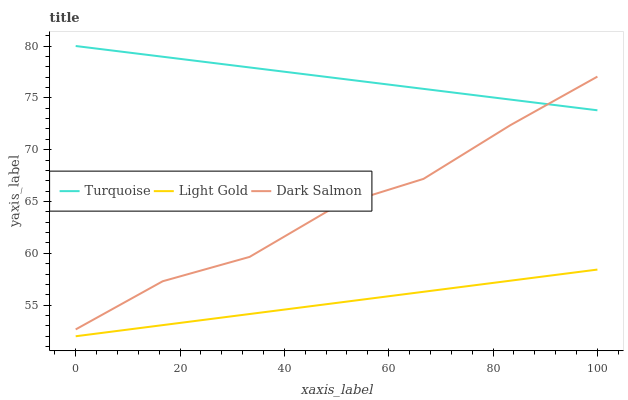Does Light Gold have the minimum area under the curve?
Answer yes or no. Yes. Does Turquoise have the maximum area under the curve?
Answer yes or no. Yes. Does Dark Salmon have the minimum area under the curve?
Answer yes or no. No. Does Dark Salmon have the maximum area under the curve?
Answer yes or no. No. Is Turquoise the smoothest?
Answer yes or no. Yes. Is Dark Salmon the roughest?
Answer yes or no. Yes. Is Dark Salmon the smoothest?
Answer yes or no. No. Is Light Gold the roughest?
Answer yes or no. No. Does Light Gold have the lowest value?
Answer yes or no. Yes. Does Dark Salmon have the lowest value?
Answer yes or no. No. Does Turquoise have the highest value?
Answer yes or no. Yes. Does Dark Salmon have the highest value?
Answer yes or no. No. Is Light Gold less than Turquoise?
Answer yes or no. Yes. Is Turquoise greater than Light Gold?
Answer yes or no. Yes. Does Turquoise intersect Dark Salmon?
Answer yes or no. Yes. Is Turquoise less than Dark Salmon?
Answer yes or no. No. Is Turquoise greater than Dark Salmon?
Answer yes or no. No. Does Light Gold intersect Turquoise?
Answer yes or no. No. 